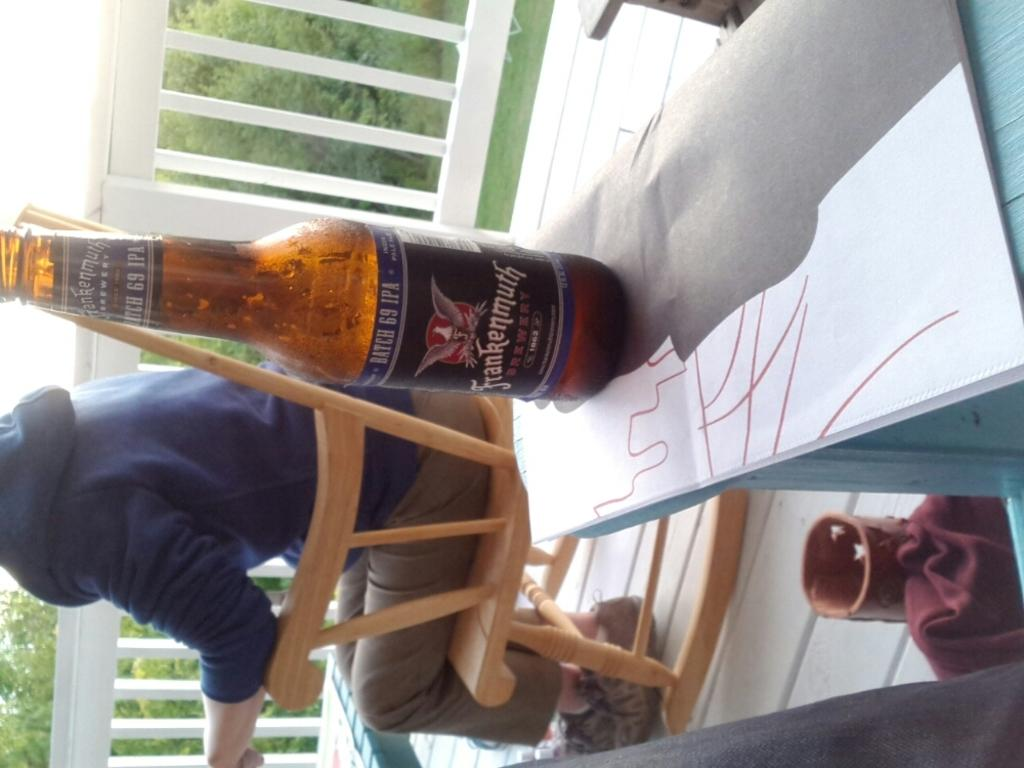<image>
Create a compact narrative representing the image presented. A bottle is from batch 69 and is on a table behind someone. 